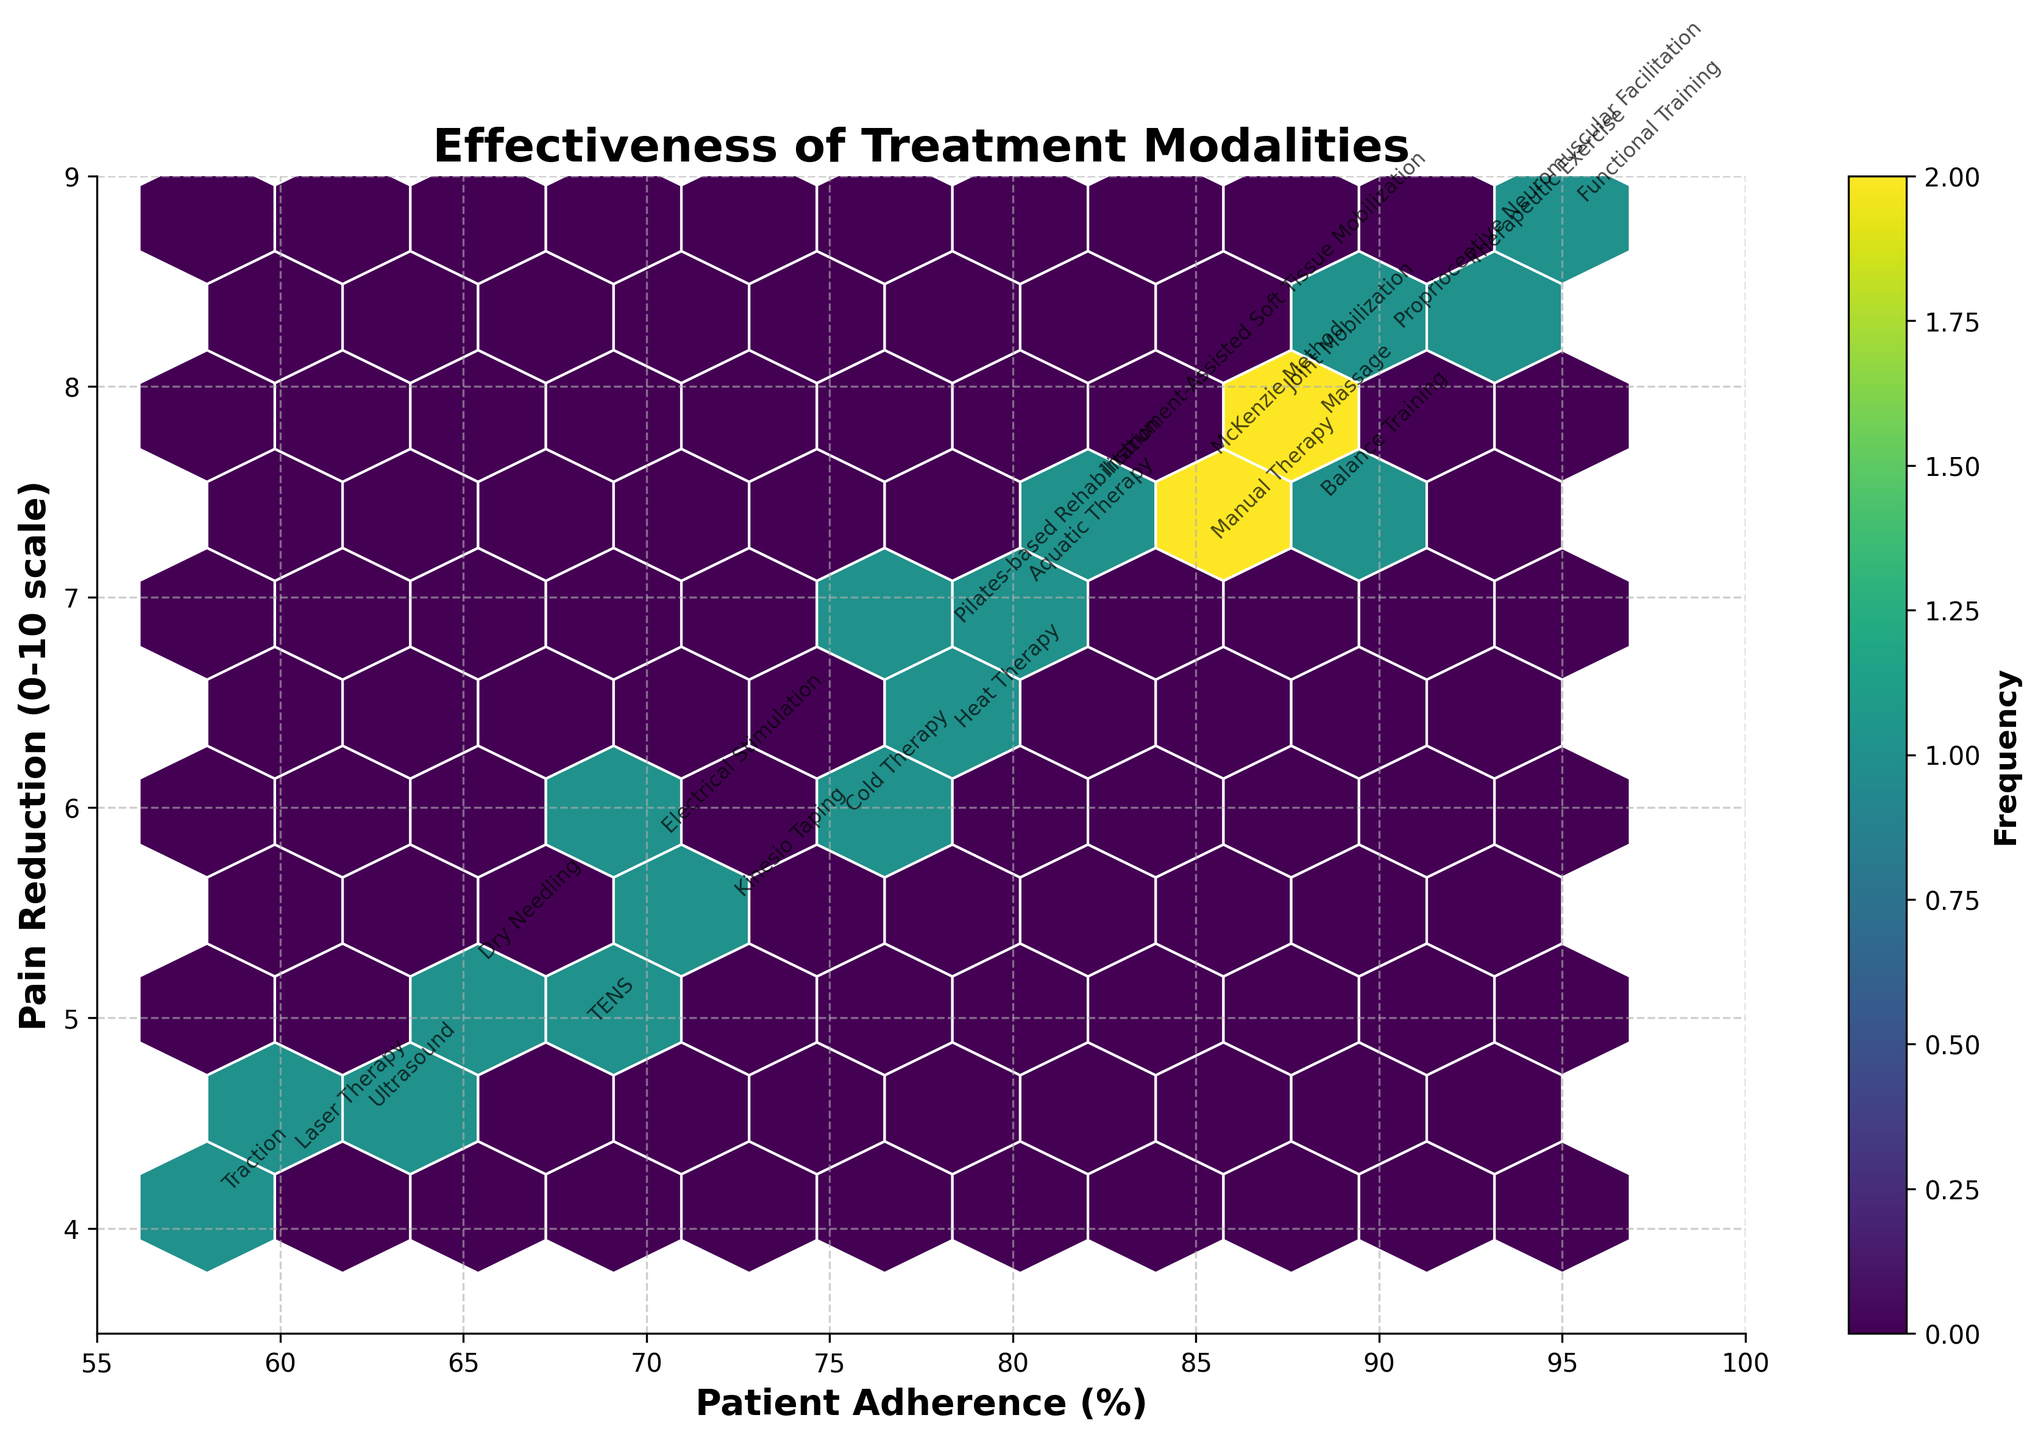What is the title of the figure? The title is located at the top of the figure and is formatted in bold.
Answer: Effectiveness of Treatment Modalities What are the x-axis and y-axis labels in the figure? The labels are found along the bottom (x-axis) and left (y-axis) sides of the figure, in a bold font.
Answer: Patient Adherence (%) and Pain Reduction (0-10 scale) Which treatment modality has the highest patient adherence and what is its corresponding pain reduction? Find the point on the plot with the highest value on the x-axis (Patient Adherence), then look at its y-axis (Pain Reduction) and the text annotation.
Answer: Functional Training with 8.8 What is the general relationship between patient adherence and pain reduction? Observing the overall trend of the points from left to right, noting how the y-values change with respect to the x-values.
Answer: Higher adherence generally correlates with higher pain reduction Which treatment modality shows the lowest pain reduction and what is its corresponding patient adherence? Find the point on the plot with the lowest value on the y-axis (Pain Reduction), then look at its x-axis (Patient Adherence) and the text annotation.
Answer: Traction with 58 How many data points have a pain reduction greater than 7? Count all the points from the plot where the y-value is greater than 7.
Answer: 10 Which treatment modality located around the center of the adherence axis, around 75-80%, has a notable pain reduction value? Identify points around the mid-range x-axis (Patient Adherence of 75-80%) and check their Pain Reduction and the respective text annotation.
Answer: Heat Therapy with 6.3 and Aquatic Therapy with 7.0 What is the color of the hexagons on the plot and what does it indicate? The color of the hexagons can be referred by looking at the color bar and the main area of the plot.
Answer: The hexagons are in shades of green and purple, indicating frequencies Which two treatment modalities have similar values for adherence and pain reduction close to 85% adherence and around 7.5-7.9 pain reduction? Look for closely located points around the mentioned plot areas and read their annotations.
Answer: Manual Therapy, McKenzie Method, and Joint Mobilization 